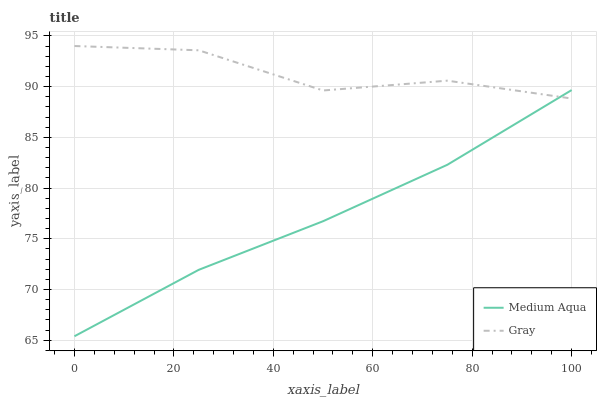Does Medium Aqua have the maximum area under the curve?
Answer yes or no. No. Is Medium Aqua the roughest?
Answer yes or no. No. Does Medium Aqua have the highest value?
Answer yes or no. No. 